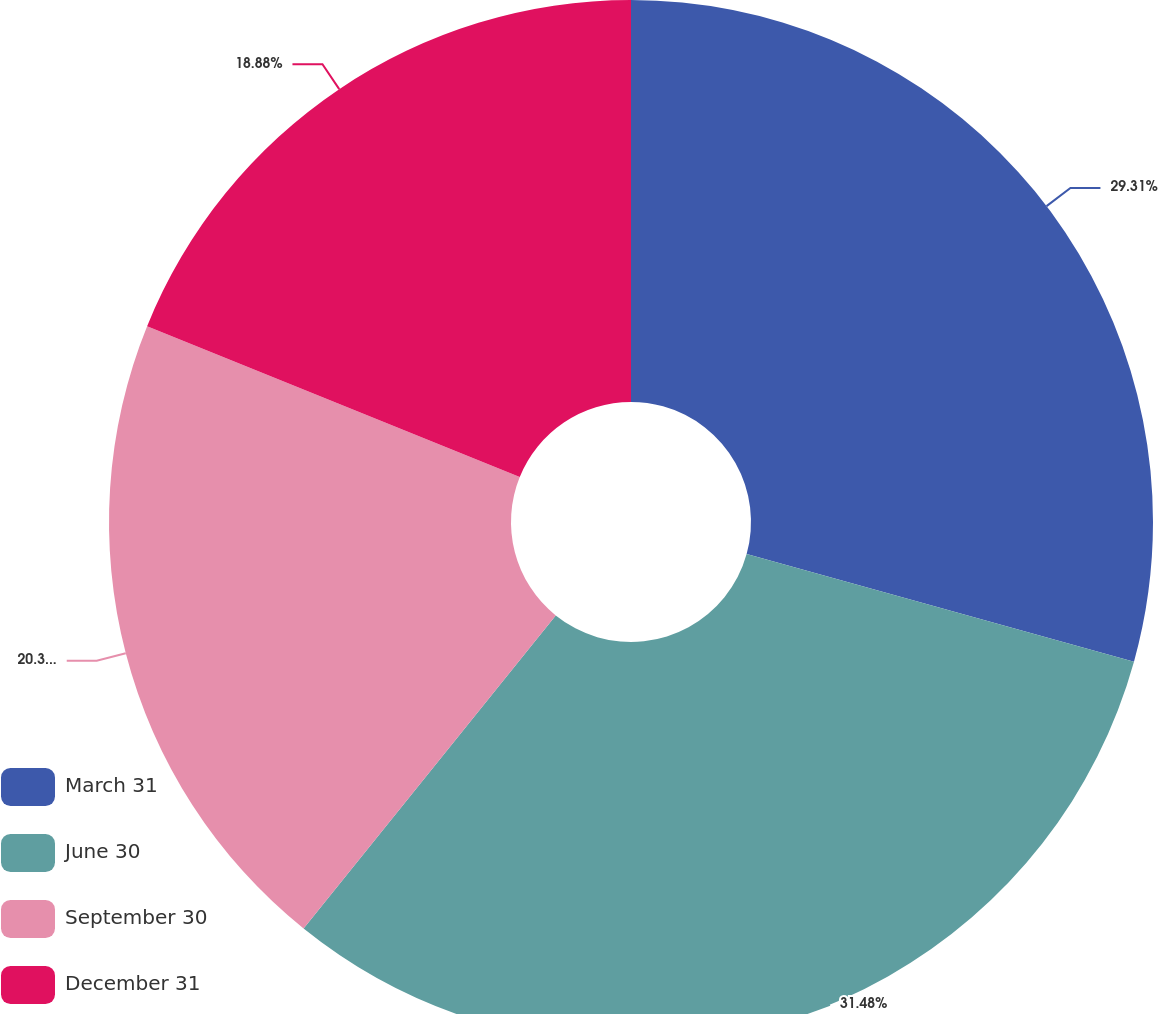Convert chart. <chart><loc_0><loc_0><loc_500><loc_500><pie_chart><fcel>March 31<fcel>June 30<fcel>September 30<fcel>December 31<nl><fcel>29.31%<fcel>31.48%<fcel>20.33%<fcel>18.88%<nl></chart> 